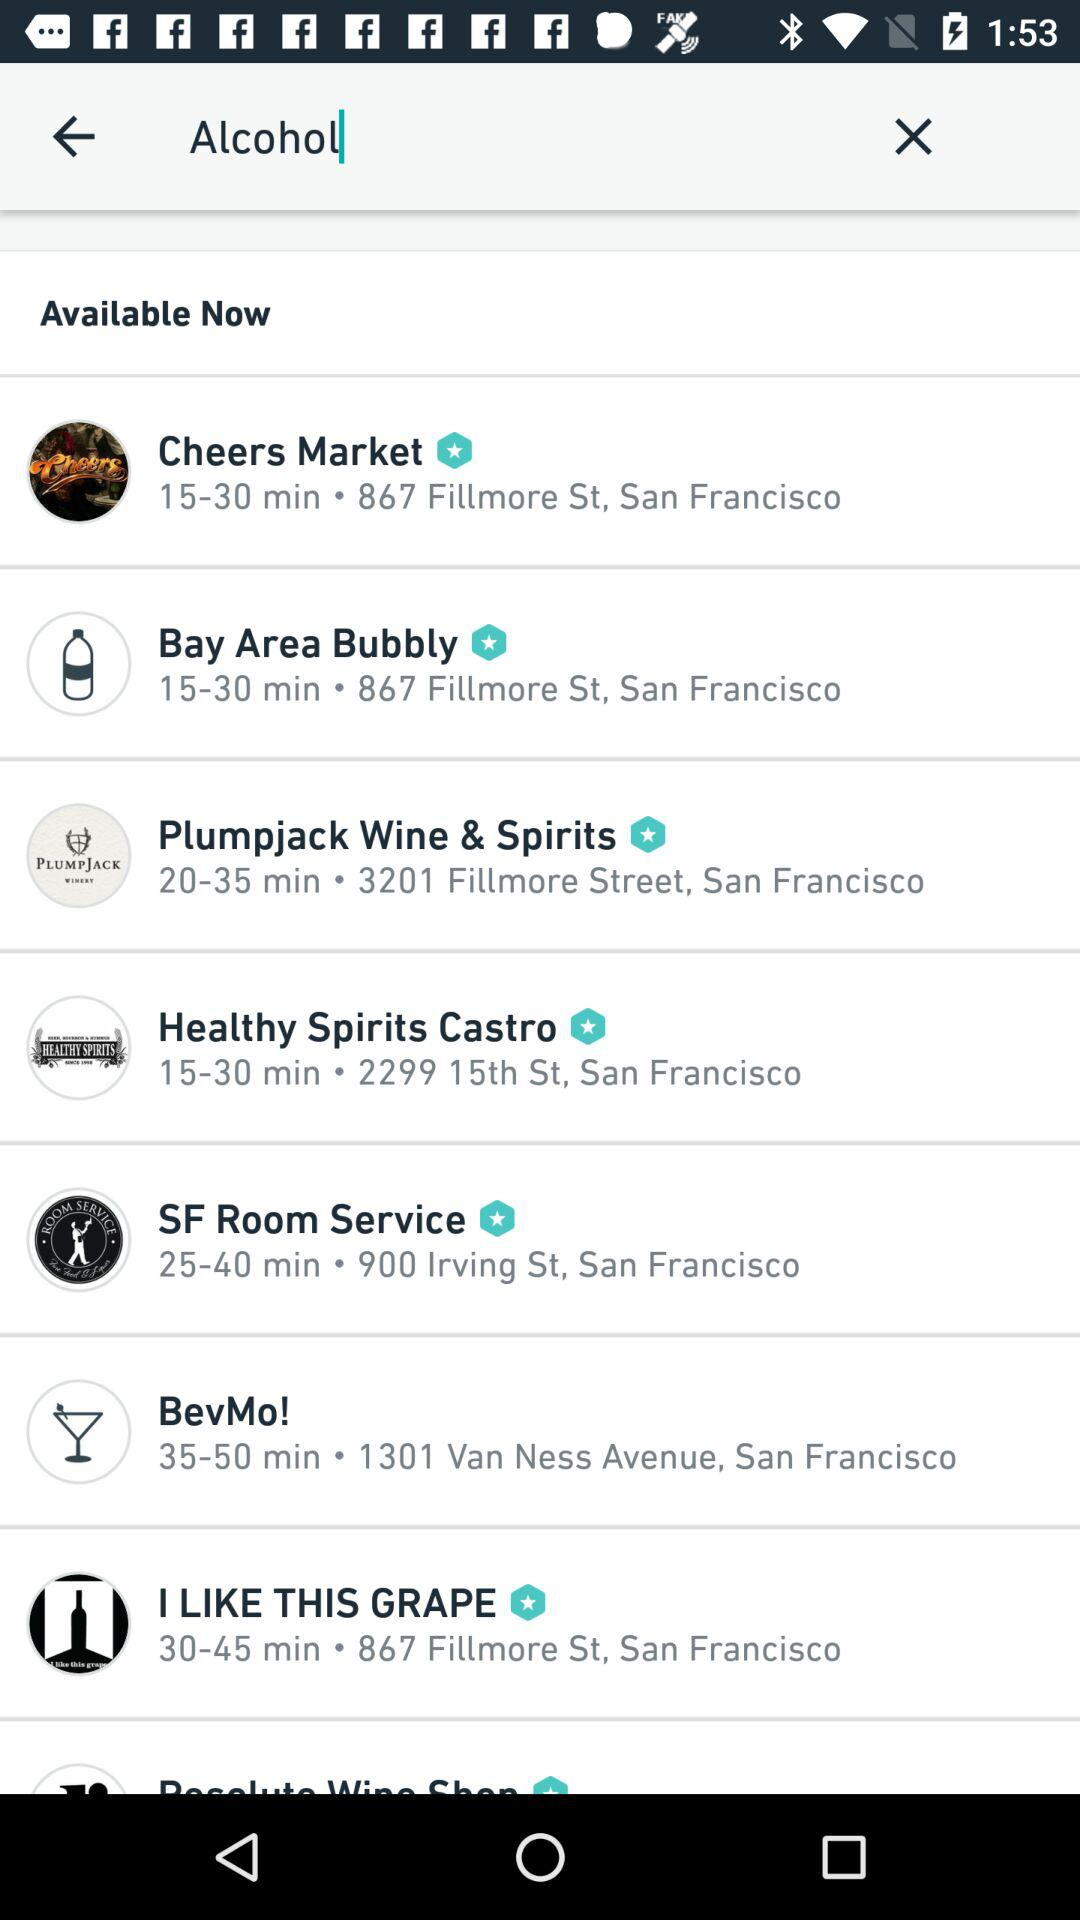Where is "Cheers Market" located? "Cheers Market" is located at 867 Fillmore St., San Francisco. 